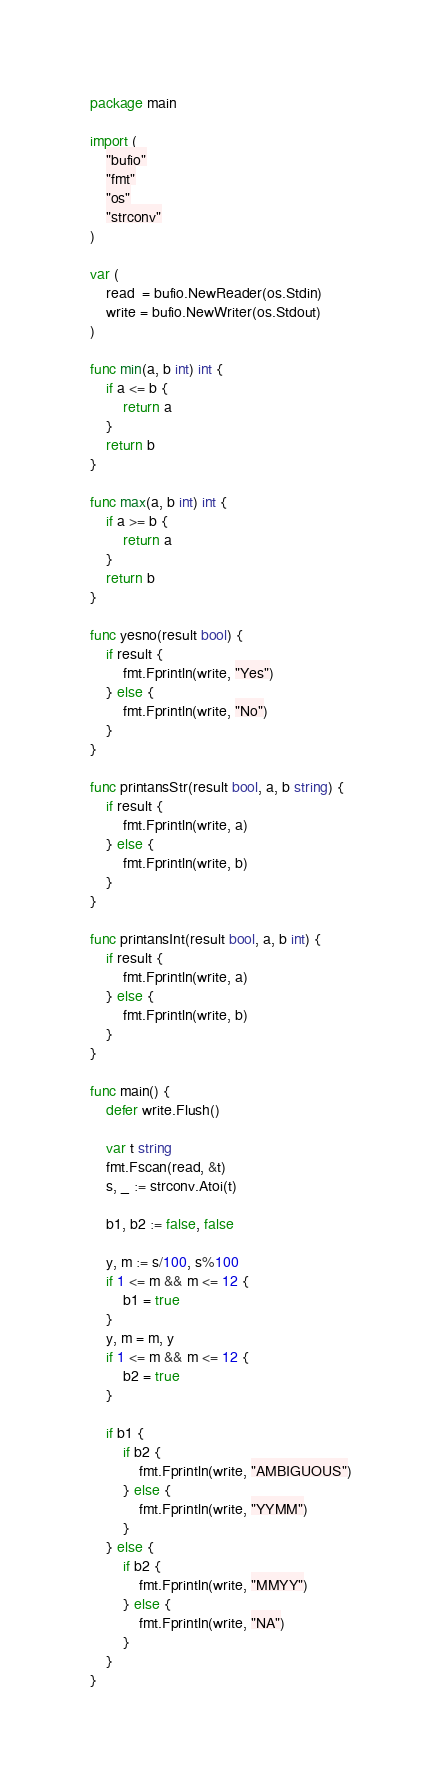<code> <loc_0><loc_0><loc_500><loc_500><_Go_>package main

import (
	"bufio"
	"fmt"
	"os"
	"strconv"
)

var (
	read  = bufio.NewReader(os.Stdin)
	write = bufio.NewWriter(os.Stdout)
)

func min(a, b int) int {
	if a <= b {
		return a
	}
	return b
}

func max(a, b int) int {
	if a >= b {
		return a
	}
	return b
}

func yesno(result bool) {
	if result {
		fmt.Fprintln(write, "Yes")
	} else {
		fmt.Fprintln(write, "No")
	}
}

func printansStr(result bool, a, b string) {
	if result {
		fmt.Fprintln(write, a)
	} else {
		fmt.Fprintln(write, b)
	}
}

func printansInt(result bool, a, b int) {
	if result {
		fmt.Fprintln(write, a)
	} else {
		fmt.Fprintln(write, b)
	}
}

func main() {
	defer write.Flush()

	var t string
	fmt.Fscan(read, &t)
	s, _ := strconv.Atoi(t)

	b1, b2 := false, false

	y, m := s/100, s%100
	if 1 <= m && m <= 12 {
		b1 = true
	}
	y, m = m, y
	if 1 <= m && m <= 12 {
		b2 = true
	}

	if b1 {
		if b2 {
			fmt.Fprintln(write, "AMBIGUOUS")
		} else {
			fmt.Fprintln(write, "YYMM")
		}
	} else {
		if b2 {
			fmt.Fprintln(write, "MMYY")
		} else {
			fmt.Fprintln(write, "NA")
		}
	}
}
</code> 